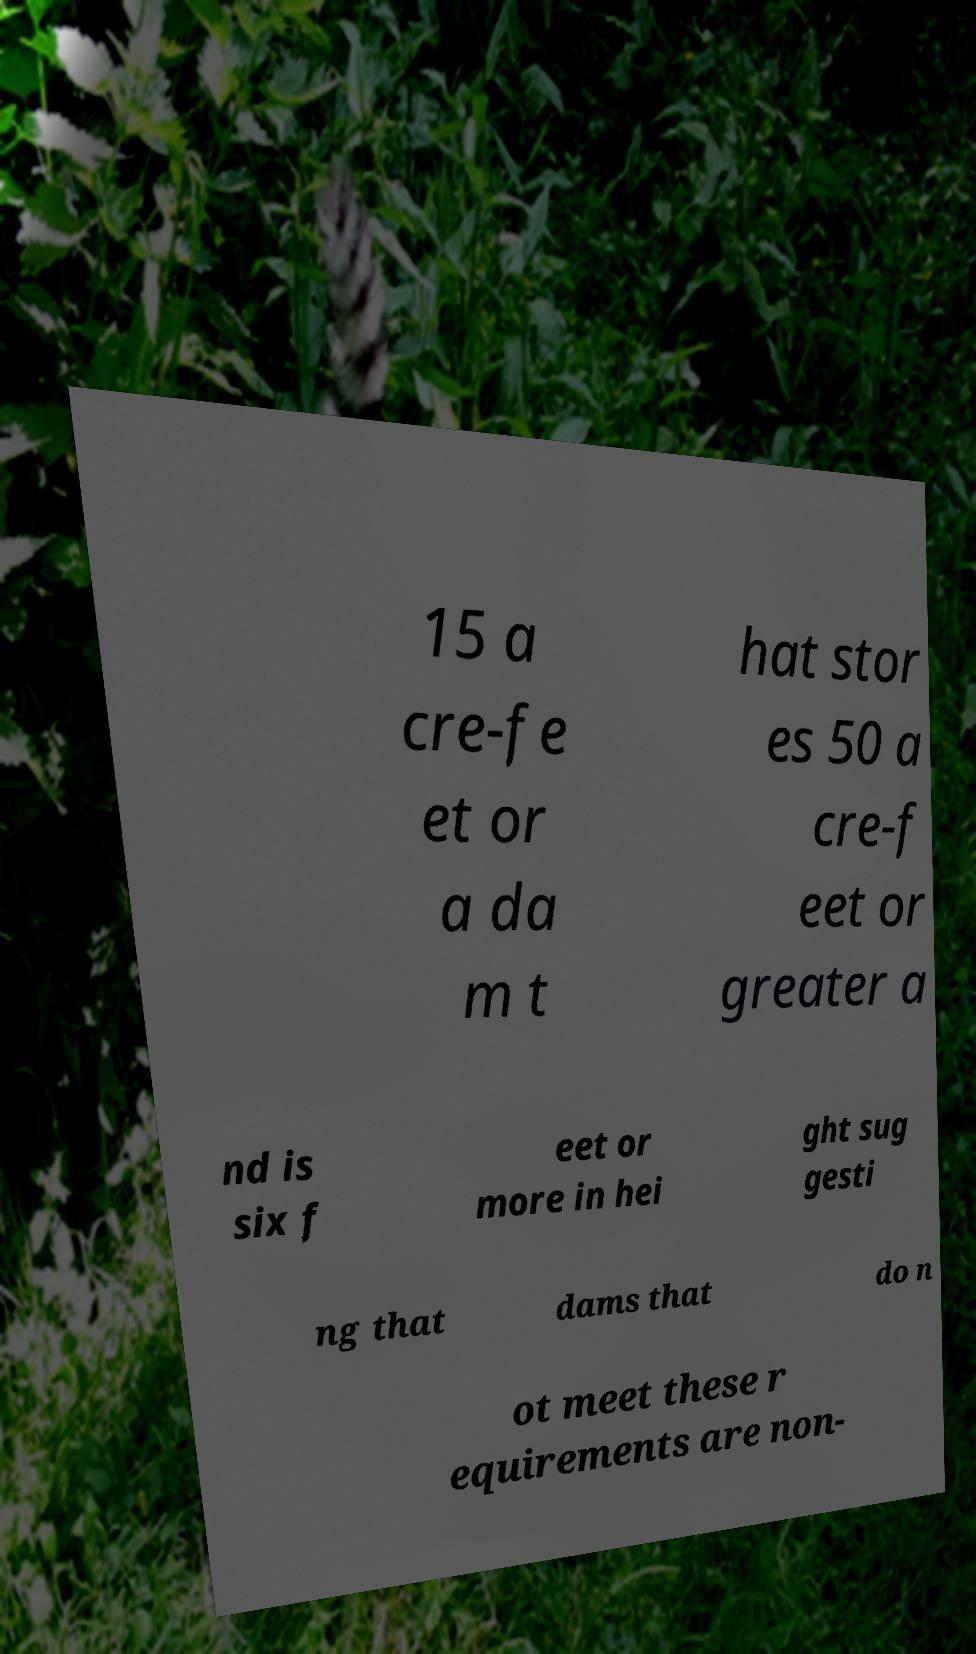There's text embedded in this image that I need extracted. Can you transcribe it verbatim? 15 a cre-fe et or a da m t hat stor es 50 a cre-f eet or greater a nd is six f eet or more in hei ght sug gesti ng that dams that do n ot meet these r equirements are non- 